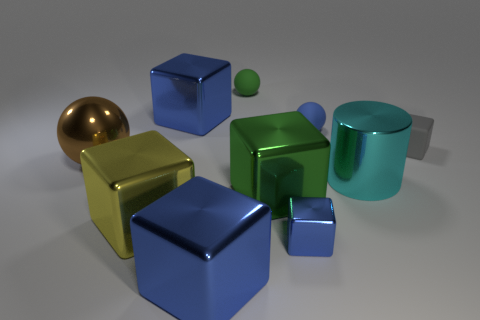Subtract all blue cylinders. How many blue cubes are left? 3 Subtract 3 blocks. How many blocks are left? 3 Subtract all yellow cubes. How many cubes are left? 5 Subtract all small gray blocks. How many blocks are left? 5 Subtract all red blocks. Subtract all gray cylinders. How many blocks are left? 6 Subtract all cubes. How many objects are left? 4 Subtract 1 green cubes. How many objects are left? 9 Subtract all balls. Subtract all brown shiny cubes. How many objects are left? 7 Add 1 big yellow cubes. How many big yellow cubes are left? 2 Add 7 big brown shiny spheres. How many big brown shiny spheres exist? 8 